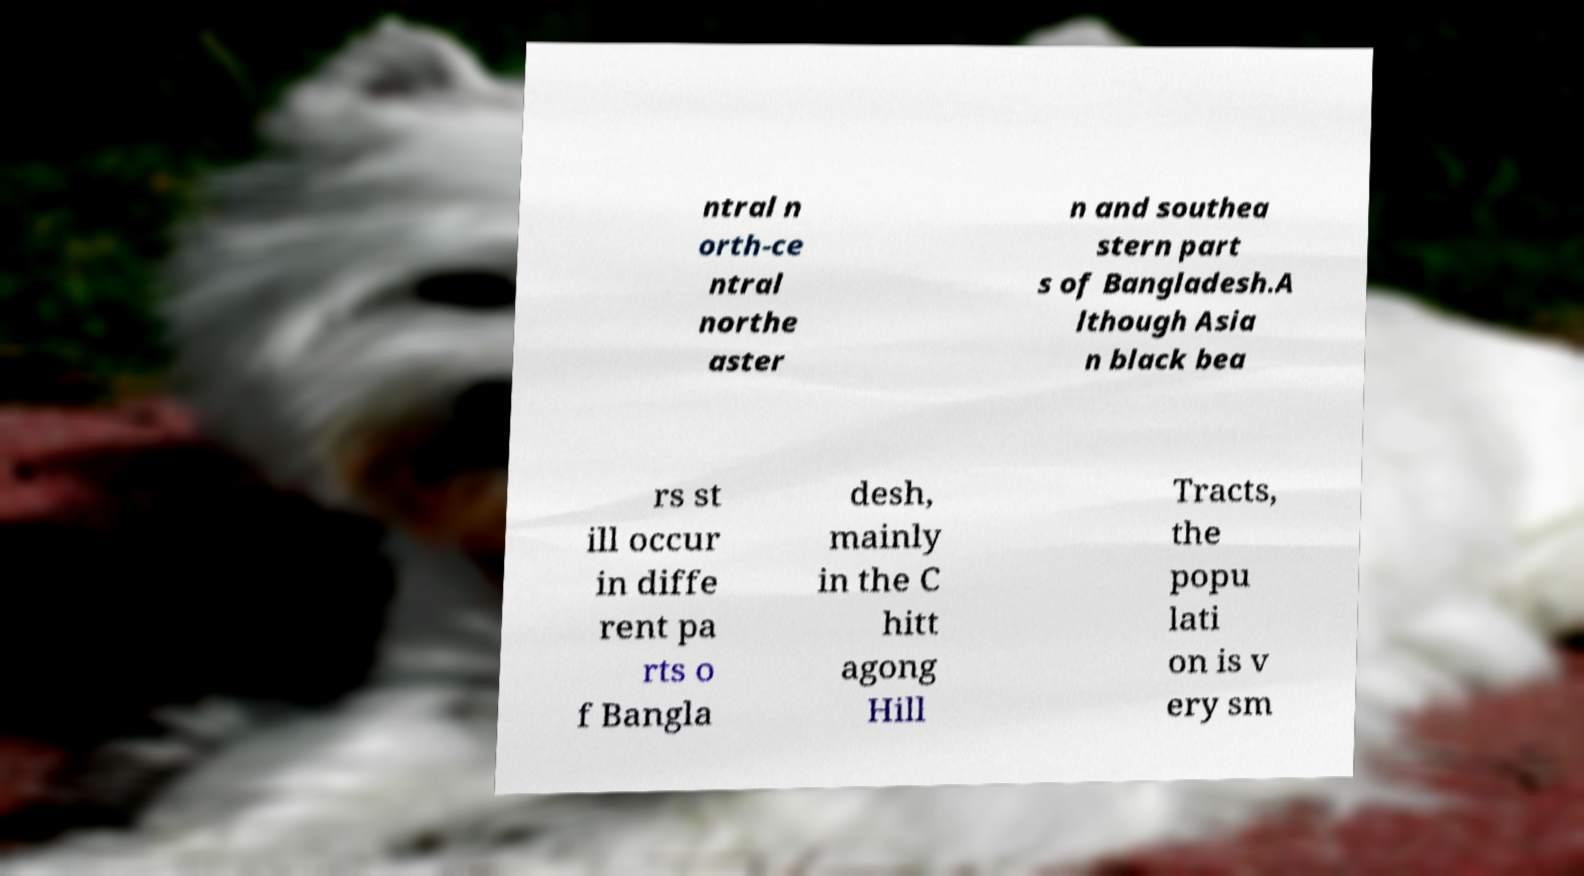For documentation purposes, I need the text within this image transcribed. Could you provide that? ntral n orth-ce ntral northe aster n and southea stern part s of Bangladesh.A lthough Asia n black bea rs st ill occur in diffe rent pa rts o f Bangla desh, mainly in the C hitt agong Hill Tracts, the popu lati on is v ery sm 